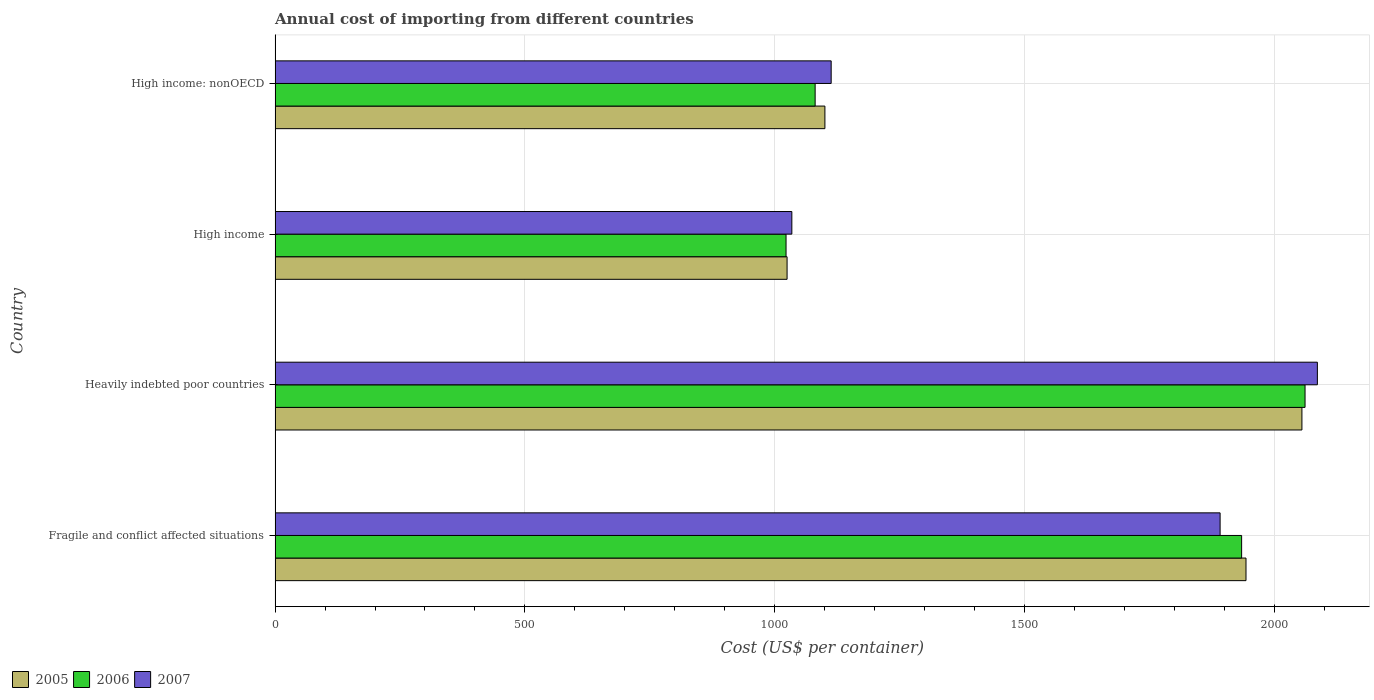How many different coloured bars are there?
Give a very brief answer. 3. Are the number of bars per tick equal to the number of legend labels?
Offer a terse response. Yes. How many bars are there on the 2nd tick from the top?
Your response must be concise. 3. How many bars are there on the 3rd tick from the bottom?
Provide a succinct answer. 3. What is the label of the 3rd group of bars from the top?
Offer a very short reply. Heavily indebted poor countries. In how many cases, is the number of bars for a given country not equal to the number of legend labels?
Your answer should be compact. 0. What is the total annual cost of importing in 2006 in Fragile and conflict affected situations?
Offer a terse response. 1934.72. Across all countries, what is the maximum total annual cost of importing in 2007?
Provide a succinct answer. 2086.37. Across all countries, what is the minimum total annual cost of importing in 2006?
Your answer should be compact. 1022.81. In which country was the total annual cost of importing in 2005 maximum?
Offer a very short reply. Heavily indebted poor countries. In which country was the total annual cost of importing in 2005 minimum?
Give a very brief answer. High income. What is the total total annual cost of importing in 2007 in the graph?
Offer a terse response. 6125.56. What is the difference between the total annual cost of importing in 2005 in Fragile and conflict affected situations and that in High income: nonOECD?
Make the answer very short. 842.9. What is the difference between the total annual cost of importing in 2006 in High income and the total annual cost of importing in 2007 in Fragile and conflict affected situations?
Keep it short and to the point. -868.84. What is the average total annual cost of importing in 2007 per country?
Your response must be concise. 1531.39. What is the difference between the total annual cost of importing in 2005 and total annual cost of importing in 2006 in High income: nonOECD?
Offer a terse response. 19.55. What is the ratio of the total annual cost of importing in 2005 in Fragile and conflict affected situations to that in High income: nonOECD?
Your answer should be compact. 1.77. Is the total annual cost of importing in 2005 in Fragile and conflict affected situations less than that in High income: nonOECD?
Your response must be concise. No. Is the difference between the total annual cost of importing in 2005 in Heavily indebted poor countries and High income greater than the difference between the total annual cost of importing in 2006 in Heavily indebted poor countries and High income?
Your answer should be very brief. No. What is the difference between the highest and the second highest total annual cost of importing in 2007?
Ensure brevity in your answer.  194.71. What is the difference between the highest and the lowest total annual cost of importing in 2005?
Give a very brief answer. 1030.55. Is the sum of the total annual cost of importing in 2006 in Fragile and conflict affected situations and High income: nonOECD greater than the maximum total annual cost of importing in 2007 across all countries?
Offer a terse response. Yes. What does the 3rd bar from the top in Fragile and conflict affected situations represents?
Make the answer very short. 2005. What is the difference between two consecutive major ticks on the X-axis?
Your response must be concise. 500. Are the values on the major ticks of X-axis written in scientific E-notation?
Provide a succinct answer. No. Does the graph contain any zero values?
Provide a short and direct response. No. Does the graph contain grids?
Give a very brief answer. Yes. Where does the legend appear in the graph?
Provide a succinct answer. Bottom left. How many legend labels are there?
Your answer should be very brief. 3. How are the legend labels stacked?
Make the answer very short. Horizontal. What is the title of the graph?
Make the answer very short. Annual cost of importing from different countries. Does "2007" appear as one of the legend labels in the graph?
Your answer should be compact. Yes. What is the label or title of the X-axis?
Your response must be concise. Cost (US$ per container). What is the label or title of the Y-axis?
Provide a succinct answer. Country. What is the Cost (US$ per container) in 2005 in Fragile and conflict affected situations?
Provide a succinct answer. 1943.5. What is the Cost (US$ per container) in 2006 in Fragile and conflict affected situations?
Offer a terse response. 1934.72. What is the Cost (US$ per container) in 2007 in Fragile and conflict affected situations?
Your response must be concise. 1891.66. What is the Cost (US$ per container) of 2005 in Heavily indebted poor countries?
Your answer should be compact. 2055.43. What is the Cost (US$ per container) of 2006 in Heavily indebted poor countries?
Your response must be concise. 2061.68. What is the Cost (US$ per container) in 2007 in Heavily indebted poor countries?
Offer a very short reply. 2086.37. What is the Cost (US$ per container) of 2005 in High income?
Provide a short and direct response. 1024.88. What is the Cost (US$ per container) of 2006 in High income?
Provide a succinct answer. 1022.81. What is the Cost (US$ per container) of 2007 in High income?
Provide a succinct answer. 1034.41. What is the Cost (US$ per container) in 2005 in High income: nonOECD?
Keep it short and to the point. 1100.6. What is the Cost (US$ per container) of 2006 in High income: nonOECD?
Offer a very short reply. 1081.05. What is the Cost (US$ per container) of 2007 in High income: nonOECD?
Your answer should be very brief. 1113.12. Across all countries, what is the maximum Cost (US$ per container) of 2005?
Make the answer very short. 2055.43. Across all countries, what is the maximum Cost (US$ per container) of 2006?
Provide a succinct answer. 2061.68. Across all countries, what is the maximum Cost (US$ per container) of 2007?
Your answer should be compact. 2086.37. Across all countries, what is the minimum Cost (US$ per container) of 2005?
Make the answer very short. 1024.88. Across all countries, what is the minimum Cost (US$ per container) in 2006?
Your answer should be very brief. 1022.81. Across all countries, what is the minimum Cost (US$ per container) of 2007?
Provide a succinct answer. 1034.41. What is the total Cost (US$ per container) in 2005 in the graph?
Make the answer very short. 6124.41. What is the total Cost (US$ per container) of 2006 in the graph?
Your response must be concise. 6100.27. What is the total Cost (US$ per container) in 2007 in the graph?
Make the answer very short. 6125.56. What is the difference between the Cost (US$ per container) in 2005 in Fragile and conflict affected situations and that in Heavily indebted poor countries?
Offer a terse response. -111.93. What is the difference between the Cost (US$ per container) in 2006 in Fragile and conflict affected situations and that in Heavily indebted poor countries?
Give a very brief answer. -126.96. What is the difference between the Cost (US$ per container) in 2007 in Fragile and conflict affected situations and that in Heavily indebted poor countries?
Offer a terse response. -194.71. What is the difference between the Cost (US$ per container) of 2005 in Fragile and conflict affected situations and that in High income?
Your answer should be very brief. 918.62. What is the difference between the Cost (US$ per container) in 2006 in Fragile and conflict affected situations and that in High income?
Your answer should be compact. 911.91. What is the difference between the Cost (US$ per container) in 2007 in Fragile and conflict affected situations and that in High income?
Ensure brevity in your answer.  857.24. What is the difference between the Cost (US$ per container) of 2005 in Fragile and conflict affected situations and that in High income: nonOECD?
Your answer should be very brief. 842.9. What is the difference between the Cost (US$ per container) in 2006 in Fragile and conflict affected situations and that in High income: nonOECD?
Your answer should be very brief. 853.68. What is the difference between the Cost (US$ per container) of 2007 in Fragile and conflict affected situations and that in High income: nonOECD?
Your response must be concise. 778.53. What is the difference between the Cost (US$ per container) of 2005 in Heavily indebted poor countries and that in High income?
Your answer should be very brief. 1030.55. What is the difference between the Cost (US$ per container) of 2006 in Heavily indebted poor countries and that in High income?
Offer a terse response. 1038.87. What is the difference between the Cost (US$ per container) of 2007 in Heavily indebted poor countries and that in High income?
Provide a succinct answer. 1051.96. What is the difference between the Cost (US$ per container) of 2005 in Heavily indebted poor countries and that in High income: nonOECD?
Keep it short and to the point. 954.83. What is the difference between the Cost (US$ per container) of 2006 in Heavily indebted poor countries and that in High income: nonOECD?
Give a very brief answer. 980.64. What is the difference between the Cost (US$ per container) of 2007 in Heavily indebted poor countries and that in High income: nonOECD?
Ensure brevity in your answer.  973.24. What is the difference between the Cost (US$ per container) of 2005 in High income and that in High income: nonOECD?
Offer a very short reply. -75.72. What is the difference between the Cost (US$ per container) of 2006 in High income and that in High income: nonOECD?
Provide a short and direct response. -58.24. What is the difference between the Cost (US$ per container) in 2007 in High income and that in High income: nonOECD?
Your answer should be very brief. -78.71. What is the difference between the Cost (US$ per container) of 2005 in Fragile and conflict affected situations and the Cost (US$ per container) of 2006 in Heavily indebted poor countries?
Offer a very short reply. -118.18. What is the difference between the Cost (US$ per container) in 2005 in Fragile and conflict affected situations and the Cost (US$ per container) in 2007 in Heavily indebted poor countries?
Offer a terse response. -142.87. What is the difference between the Cost (US$ per container) of 2006 in Fragile and conflict affected situations and the Cost (US$ per container) of 2007 in Heavily indebted poor countries?
Offer a very short reply. -151.64. What is the difference between the Cost (US$ per container) in 2005 in Fragile and conflict affected situations and the Cost (US$ per container) in 2006 in High income?
Keep it short and to the point. 920.69. What is the difference between the Cost (US$ per container) in 2005 in Fragile and conflict affected situations and the Cost (US$ per container) in 2007 in High income?
Offer a terse response. 909.09. What is the difference between the Cost (US$ per container) in 2006 in Fragile and conflict affected situations and the Cost (US$ per container) in 2007 in High income?
Make the answer very short. 900.31. What is the difference between the Cost (US$ per container) of 2005 in Fragile and conflict affected situations and the Cost (US$ per container) of 2006 in High income: nonOECD?
Ensure brevity in your answer.  862.45. What is the difference between the Cost (US$ per container) in 2005 in Fragile and conflict affected situations and the Cost (US$ per container) in 2007 in High income: nonOECD?
Provide a short and direct response. 830.38. What is the difference between the Cost (US$ per container) in 2006 in Fragile and conflict affected situations and the Cost (US$ per container) in 2007 in High income: nonOECD?
Your answer should be compact. 821.6. What is the difference between the Cost (US$ per container) of 2005 in Heavily indebted poor countries and the Cost (US$ per container) of 2006 in High income?
Your answer should be very brief. 1032.62. What is the difference between the Cost (US$ per container) in 2005 in Heavily indebted poor countries and the Cost (US$ per container) in 2007 in High income?
Your answer should be compact. 1021.02. What is the difference between the Cost (US$ per container) in 2006 in Heavily indebted poor countries and the Cost (US$ per container) in 2007 in High income?
Give a very brief answer. 1027.27. What is the difference between the Cost (US$ per container) in 2005 in Heavily indebted poor countries and the Cost (US$ per container) in 2006 in High income: nonOECD?
Your answer should be very brief. 974.38. What is the difference between the Cost (US$ per container) in 2005 in Heavily indebted poor countries and the Cost (US$ per container) in 2007 in High income: nonOECD?
Give a very brief answer. 942.31. What is the difference between the Cost (US$ per container) of 2006 in Heavily indebted poor countries and the Cost (US$ per container) of 2007 in High income: nonOECD?
Ensure brevity in your answer.  948.56. What is the difference between the Cost (US$ per container) in 2005 in High income and the Cost (US$ per container) in 2006 in High income: nonOECD?
Give a very brief answer. -56.17. What is the difference between the Cost (US$ per container) of 2005 in High income and the Cost (US$ per container) of 2007 in High income: nonOECD?
Keep it short and to the point. -88.24. What is the difference between the Cost (US$ per container) of 2006 in High income and the Cost (US$ per container) of 2007 in High income: nonOECD?
Provide a short and direct response. -90.31. What is the average Cost (US$ per container) in 2005 per country?
Provide a succinct answer. 1531.1. What is the average Cost (US$ per container) in 2006 per country?
Your answer should be compact. 1525.07. What is the average Cost (US$ per container) of 2007 per country?
Keep it short and to the point. 1531.39. What is the difference between the Cost (US$ per container) of 2005 and Cost (US$ per container) of 2006 in Fragile and conflict affected situations?
Offer a terse response. 8.78. What is the difference between the Cost (US$ per container) in 2005 and Cost (US$ per container) in 2007 in Fragile and conflict affected situations?
Offer a terse response. 51.84. What is the difference between the Cost (US$ per container) in 2006 and Cost (US$ per container) in 2007 in Fragile and conflict affected situations?
Provide a succinct answer. 43.07. What is the difference between the Cost (US$ per container) of 2005 and Cost (US$ per container) of 2006 in Heavily indebted poor countries?
Provide a short and direct response. -6.25. What is the difference between the Cost (US$ per container) in 2005 and Cost (US$ per container) in 2007 in Heavily indebted poor countries?
Your answer should be compact. -30.94. What is the difference between the Cost (US$ per container) in 2006 and Cost (US$ per container) in 2007 in Heavily indebted poor countries?
Keep it short and to the point. -24.68. What is the difference between the Cost (US$ per container) of 2005 and Cost (US$ per container) of 2006 in High income?
Make the answer very short. 2.07. What is the difference between the Cost (US$ per container) in 2005 and Cost (US$ per container) in 2007 in High income?
Provide a succinct answer. -9.53. What is the difference between the Cost (US$ per container) in 2006 and Cost (US$ per container) in 2007 in High income?
Offer a terse response. -11.6. What is the difference between the Cost (US$ per container) in 2005 and Cost (US$ per container) in 2006 in High income: nonOECD?
Offer a very short reply. 19.55. What is the difference between the Cost (US$ per container) of 2005 and Cost (US$ per container) of 2007 in High income: nonOECD?
Ensure brevity in your answer.  -12.53. What is the difference between the Cost (US$ per container) in 2006 and Cost (US$ per container) in 2007 in High income: nonOECD?
Offer a very short reply. -32.08. What is the ratio of the Cost (US$ per container) of 2005 in Fragile and conflict affected situations to that in Heavily indebted poor countries?
Make the answer very short. 0.95. What is the ratio of the Cost (US$ per container) of 2006 in Fragile and conflict affected situations to that in Heavily indebted poor countries?
Give a very brief answer. 0.94. What is the ratio of the Cost (US$ per container) in 2007 in Fragile and conflict affected situations to that in Heavily indebted poor countries?
Make the answer very short. 0.91. What is the ratio of the Cost (US$ per container) in 2005 in Fragile and conflict affected situations to that in High income?
Make the answer very short. 1.9. What is the ratio of the Cost (US$ per container) of 2006 in Fragile and conflict affected situations to that in High income?
Provide a short and direct response. 1.89. What is the ratio of the Cost (US$ per container) in 2007 in Fragile and conflict affected situations to that in High income?
Give a very brief answer. 1.83. What is the ratio of the Cost (US$ per container) of 2005 in Fragile and conflict affected situations to that in High income: nonOECD?
Give a very brief answer. 1.77. What is the ratio of the Cost (US$ per container) in 2006 in Fragile and conflict affected situations to that in High income: nonOECD?
Offer a terse response. 1.79. What is the ratio of the Cost (US$ per container) of 2007 in Fragile and conflict affected situations to that in High income: nonOECD?
Offer a very short reply. 1.7. What is the ratio of the Cost (US$ per container) of 2005 in Heavily indebted poor countries to that in High income?
Your answer should be compact. 2.01. What is the ratio of the Cost (US$ per container) in 2006 in Heavily indebted poor countries to that in High income?
Keep it short and to the point. 2.02. What is the ratio of the Cost (US$ per container) of 2007 in Heavily indebted poor countries to that in High income?
Provide a succinct answer. 2.02. What is the ratio of the Cost (US$ per container) of 2005 in Heavily indebted poor countries to that in High income: nonOECD?
Your answer should be very brief. 1.87. What is the ratio of the Cost (US$ per container) in 2006 in Heavily indebted poor countries to that in High income: nonOECD?
Keep it short and to the point. 1.91. What is the ratio of the Cost (US$ per container) of 2007 in Heavily indebted poor countries to that in High income: nonOECD?
Make the answer very short. 1.87. What is the ratio of the Cost (US$ per container) in 2005 in High income to that in High income: nonOECD?
Provide a short and direct response. 0.93. What is the ratio of the Cost (US$ per container) in 2006 in High income to that in High income: nonOECD?
Offer a terse response. 0.95. What is the ratio of the Cost (US$ per container) of 2007 in High income to that in High income: nonOECD?
Keep it short and to the point. 0.93. What is the difference between the highest and the second highest Cost (US$ per container) in 2005?
Your answer should be very brief. 111.93. What is the difference between the highest and the second highest Cost (US$ per container) in 2006?
Your answer should be very brief. 126.96. What is the difference between the highest and the second highest Cost (US$ per container) in 2007?
Provide a succinct answer. 194.71. What is the difference between the highest and the lowest Cost (US$ per container) of 2005?
Offer a very short reply. 1030.55. What is the difference between the highest and the lowest Cost (US$ per container) in 2006?
Your answer should be compact. 1038.87. What is the difference between the highest and the lowest Cost (US$ per container) of 2007?
Your answer should be compact. 1051.96. 